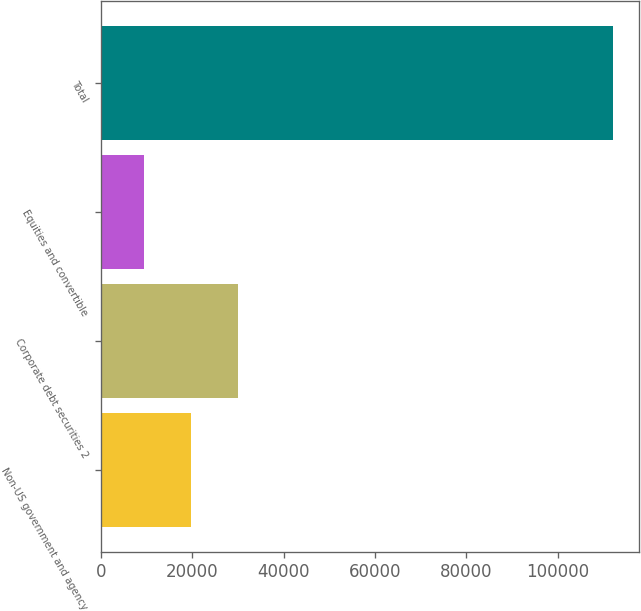Convert chart to OTSL. <chart><loc_0><loc_0><loc_500><loc_500><bar_chart><fcel>Non-US government and agency<fcel>Corporate debt securities 2<fcel>Equities and convertible<fcel>Total<nl><fcel>19671.5<fcel>29949<fcel>9394<fcel>112169<nl></chart> 